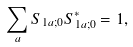<formula> <loc_0><loc_0><loc_500><loc_500>\sum _ { a } S _ { 1 a ; 0 } S _ { 1 a ; 0 } ^ { * } = 1 ,</formula> 